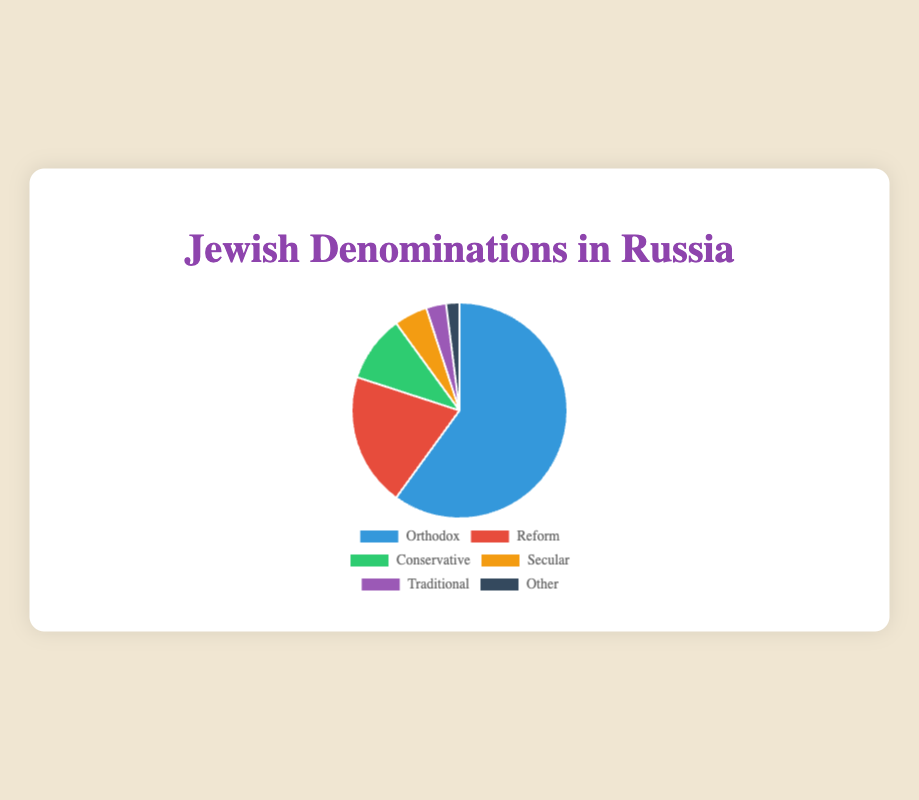What's the proportion of Orthodox Jews in Russia? The pie chart shows a segment labeled "Orthodox" corresponding to 60%.
Answer: 60% Which denomination has the smallest proportion? The pie chart lists "Other" with a proportion of 2%, which is the smallest among all denominations.
Answer: Other Compare the proportion of Reform and Conservative Jews. Which group is larger and by how much? The proportion of Reform Jews is 20%, and the proportion of Conservative Jews is 10%. Reform is larger by the difference of their proportions: 20% - 10% = 10%.
Answer: Reform, 10% What is the sum of the proportions of Secular and Traditional Jews? The pie chart shows Secular Jews have a proportion of 5%, and Traditional Jews have 3%. The sum is 5% + 3% = 8%.
Answer: 8% What is the total proportion of non-Orthodox denominations (Reform, Conservative, Secular, Traditional, and Other)? Sum the proportions: Reform (20%) + Conservative (10%) + Secular (5%) + Traditional (3%) + Other (2%) = 40%.
Answer: 40% Visually comparing the chart, which denomination is represented by a red segment? The red segment corresponds to the Reform denomination, as described in the visual attributes.
Answer: Reform What percentage more is the proportion of Orthodox Jews compared to Reform Jews? Orthodox Jews are at 60%, and Reform Jews are at 20%. The difference is 60% - 20% = 40%. Thus, Orthodox Jews have a 40% higher proportion.
Answer: 40% Among the denominations shown, which ones have a proportion less than 10%? The denominations with proportions less than 10% are Secular (5%), Traditional (3%), and Other (2%).
Answer: Secular, Traditional, Other 